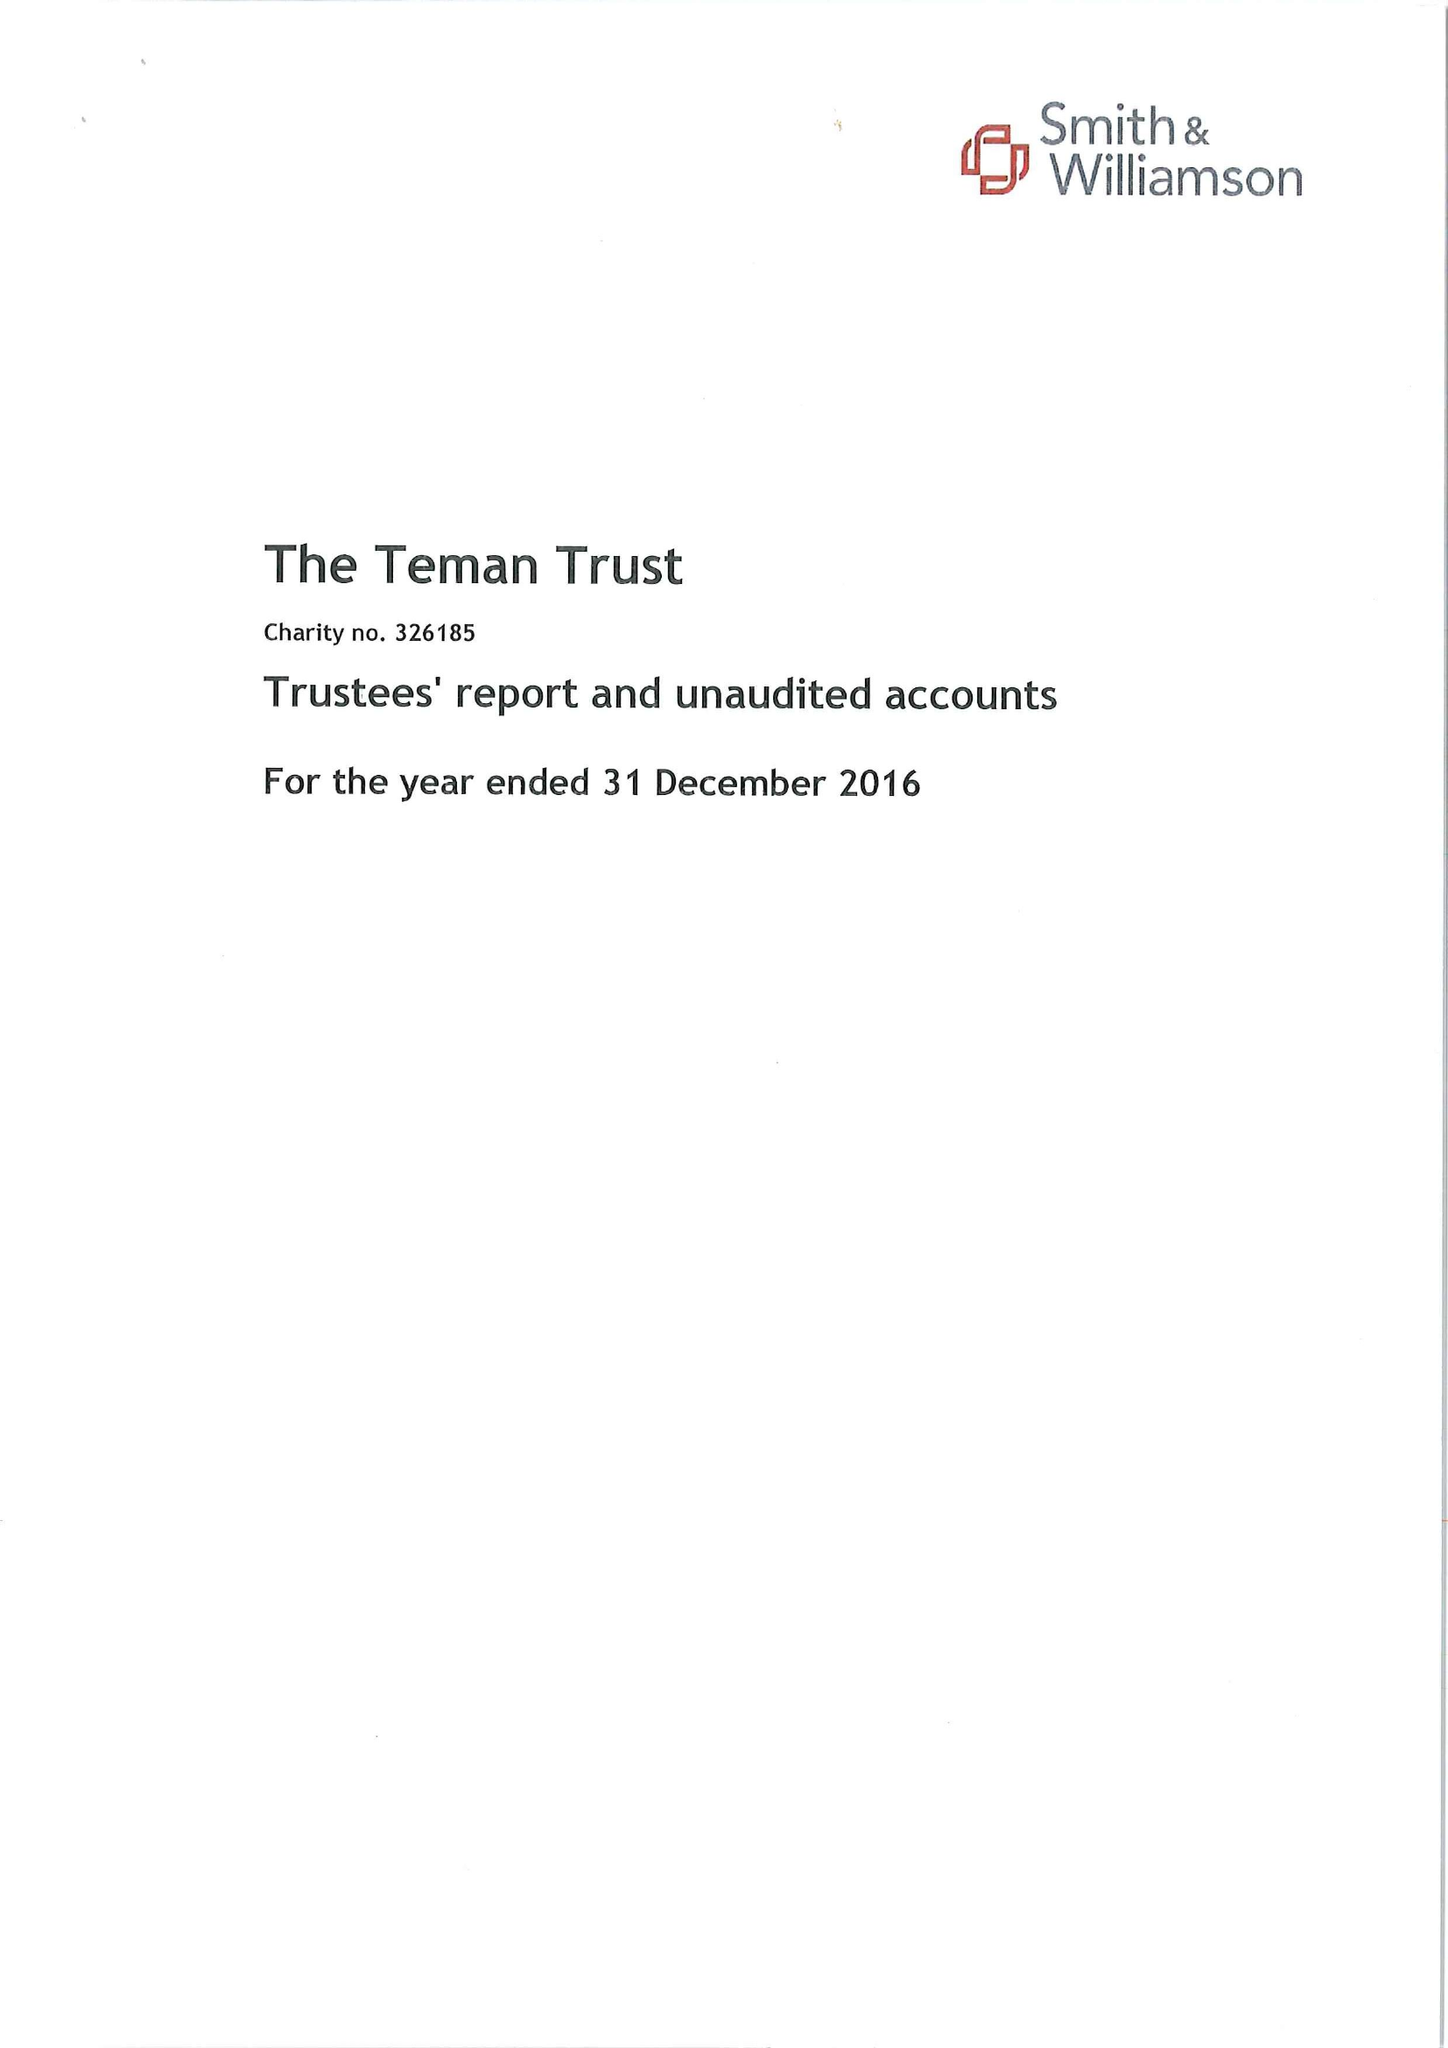What is the value for the address__street_line?
Answer the question using a single word or phrase. None 